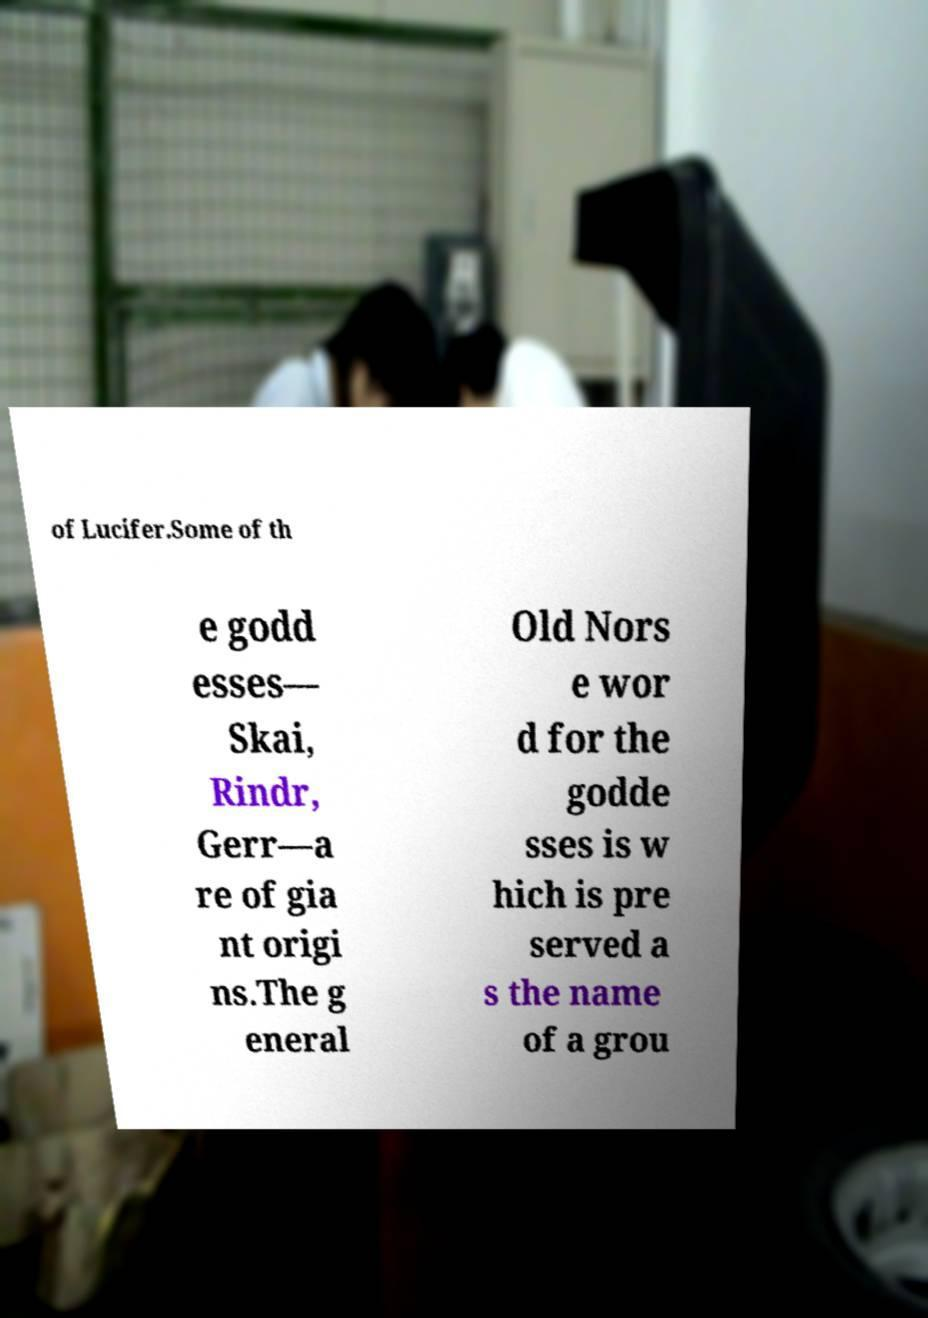There's text embedded in this image that I need extracted. Can you transcribe it verbatim? of Lucifer.Some of th e godd esses— Skai, Rindr, Gerr—a re of gia nt origi ns.The g eneral Old Nors e wor d for the godde sses is w hich is pre served a s the name of a grou 